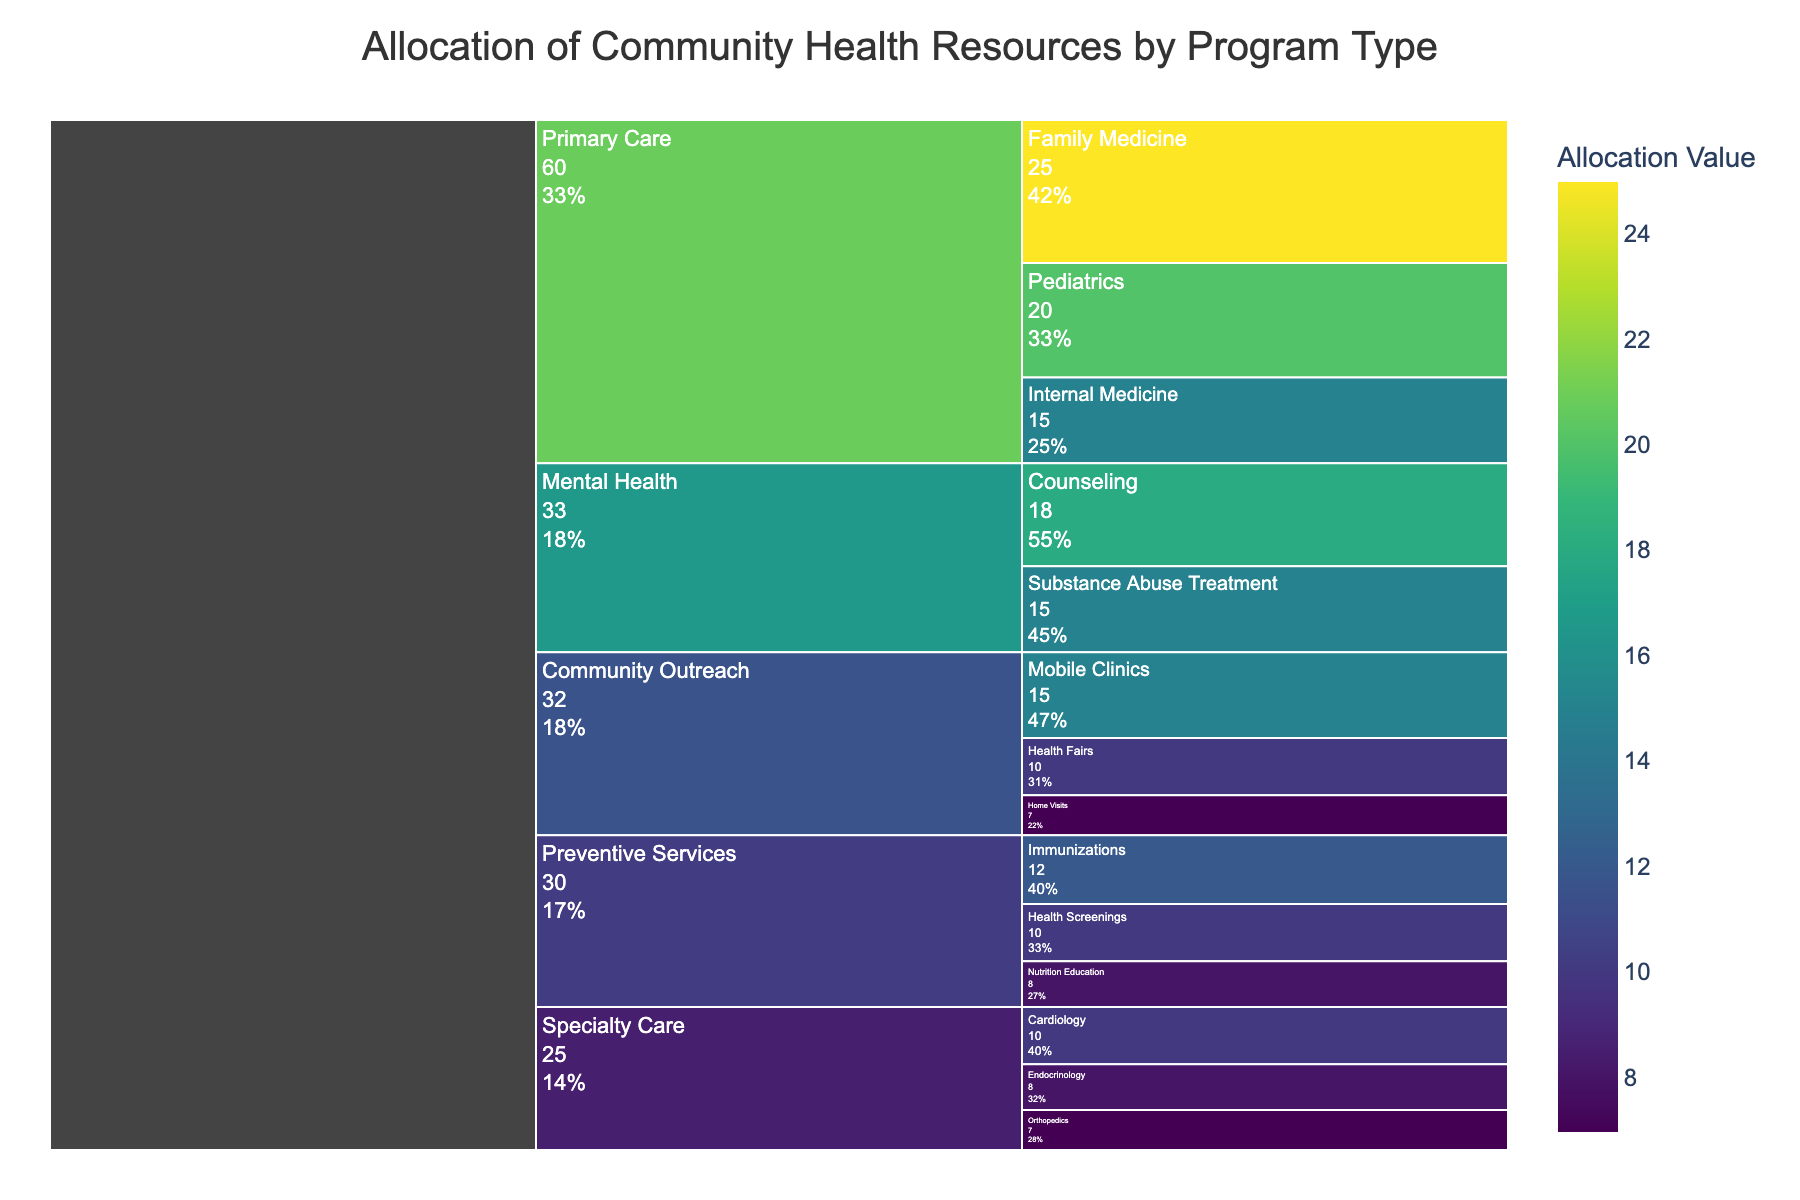What is the title of the figure? The title is typically located at the top of the chart, and it provides a brief description of what the chart is about. In this case, it shows the allocation of community health resources by different program types.
Answer: Allocation of Community Health Resources by Program Type Which subcategory within Primary Care has the highest allocation value? To find this, look under the "Primary Care" category in the chart and identify which subcategory has the largest value.
Answer: Family Medicine What is the total allocation value for all Primary Care subcategories? Add the values of all subcategories under Primary Care (Family Medicine: 25, Pediatrics: 20, Internal Medicine: 15). The total is 25 + 20 + 15
Answer: 60 How does the allocation for Immunizations compare to Nutrition Education? Locate both subcategories under Preventive Services and compare their values. Immunizations have a value of 12, while Nutrition Education has a value of 8. This means Immunizations have a higher allocation.
Answer: Immunizations have a higher allocation Which category has the highest overall allocation value? Sum the respective subcategories' values under each main category and compare. The category with the highest sum is the one with the highest overall allocation.
Answer: Primary Care What percentage of the total allocation does Mental Health represent? First, calculate the total allocation value by summing up all the values. Then, sum the values under Mental Health (Counseling: 18, Substance Abuse Treatment: 15) to get 33. Finally, divide the Mental Health total by the overall total and multiply by 100 for the percentage.
Answer: 21.1% How many subcategories are there under Community Outreach? Count the number of subcategories within the Community Outreach category. The subcategories are Mobile Clinics, Health Fairs, and Home Visits.
Answer: 3 Which subcategory under Specialty Care has the lowest allocation value? Look under the Specialty Care category and identify the subcategory with the smallest value.
Answer: Orthopedics What is the combined allocation value for Counseling, Pediatrics, and Endocrinology? Add the values for Counseling (18), Pediatrics (20), and Endocrinology (8). The combined value is 18 + 20 + 8
Answer: 46 Which category has more subcategories, Preventive Services or Community Outreach? Count the subcategories under each category. Preventive Services has Immunizations, Health Screenings, and Nutrition Education (3), while Community Outreach has Mobile Clinics, Health Fairs, and Home Visits (3).
Answer: They have an equal number 